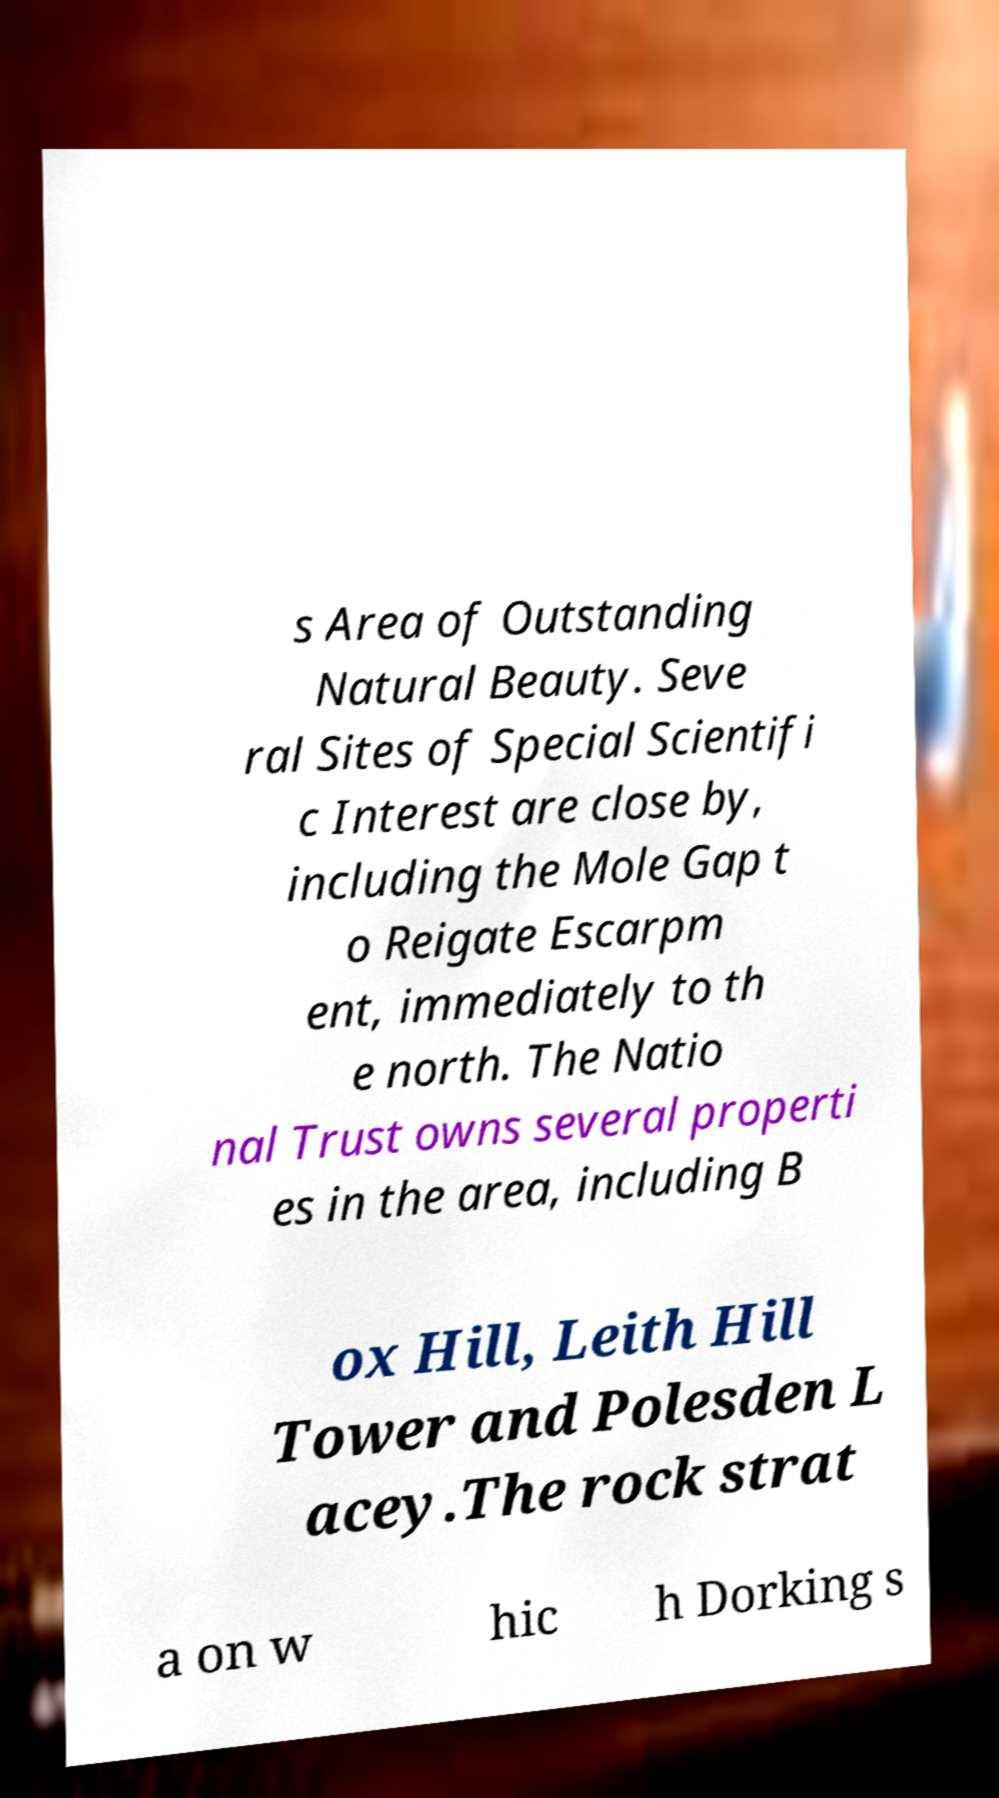Please identify and transcribe the text found in this image. s Area of Outstanding Natural Beauty. Seve ral Sites of Special Scientifi c Interest are close by, including the Mole Gap t o Reigate Escarpm ent, immediately to th e north. The Natio nal Trust owns several properti es in the area, including B ox Hill, Leith Hill Tower and Polesden L acey.The rock strat a on w hic h Dorking s 